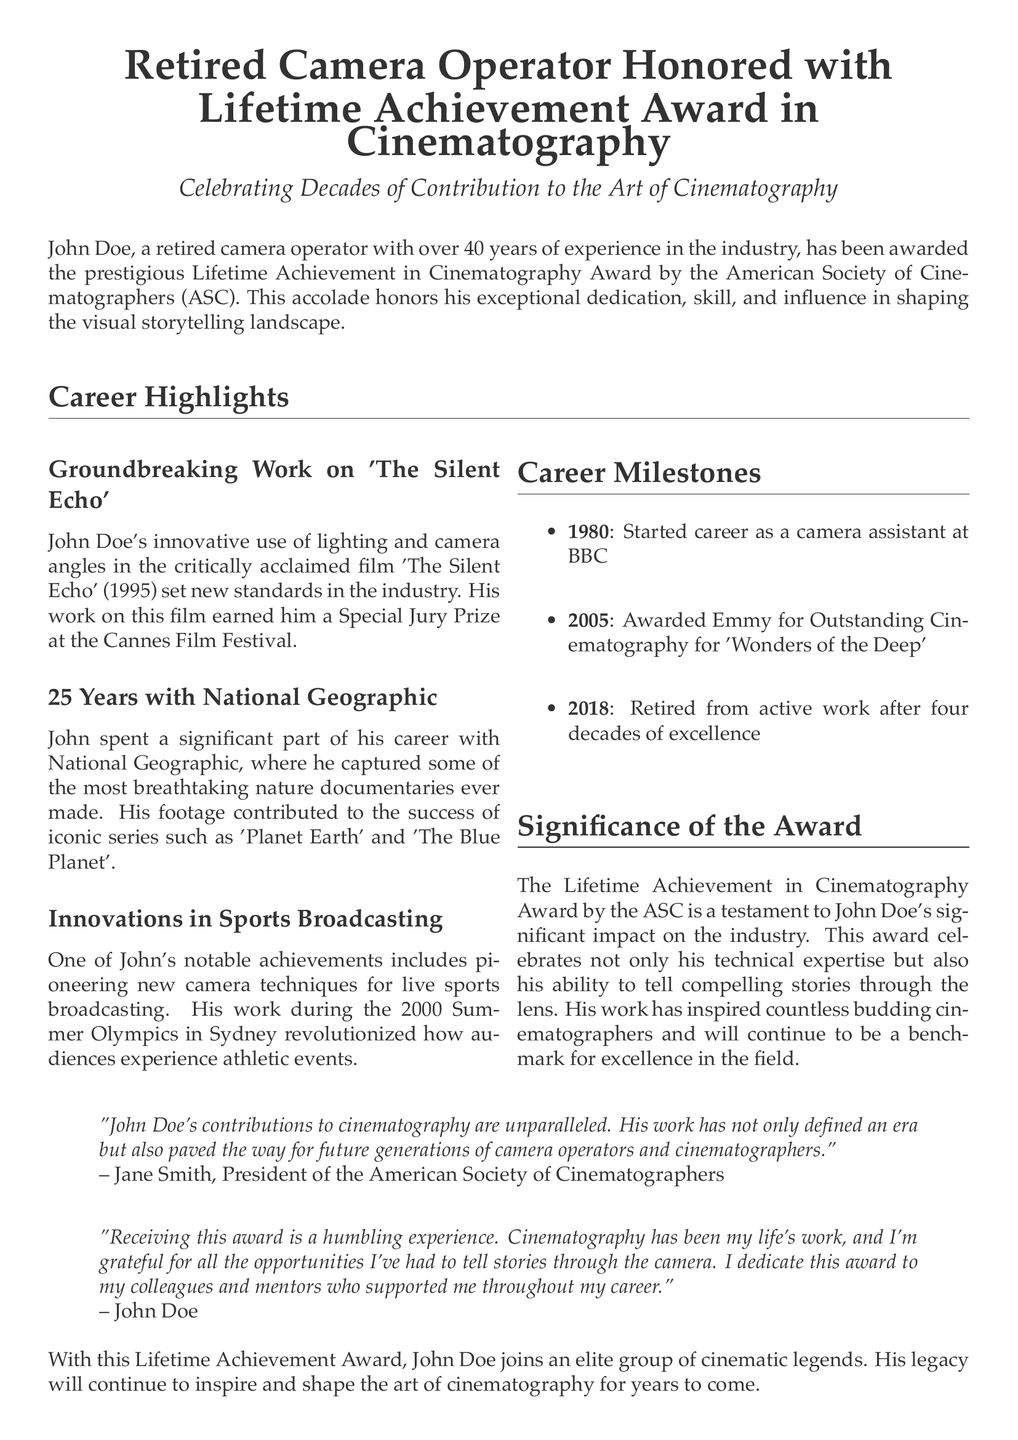What award did John Doe receive? The document states that John Doe was awarded the Lifetime Achievement in Cinematography Award by the American Society of Cinematographers.
Answer: Lifetime Achievement in Cinematography Award How many years of experience does John Doe have in the industry? It is mentioned that John Doe has over 40 years of experience in the industry.
Answer: 40 years What film earned John Doe a Special Jury Prize? The document specifies that John Doe's work in the film 'The Silent Echo' earned him a Special Jury Prize.
Answer: The Silent Echo In what year did John Doe start his career? The press release states that John Doe started his career in 1980.
Answer: 1980 What was one of John Doe's notable achievements at the 2000 Summer Olympics? The achievement mentioned in the document refers to pioneering new camera techniques for live sports broadcasting.
Answer: New camera techniques for live sports broadcasting What series did John Doe contribute to while working with National Geographic? The document highlights that John Doe contributed to iconic series such as 'Planet Earth' and 'The Blue Planet'.
Answer: Planet Earth and The Blue Planet Why is the Lifetime Achievement Award significant? The significance of the award lies in honoring John Doe's impact on the industry and his storytelling ability through the lens.
Answer: Impact on the industry Who is the president of the American Society of Cinematographers mentioned in the document? Jane Smith is identified as the president of the American Society of Cinematographers in the press release.
Answer: Jane Smith 